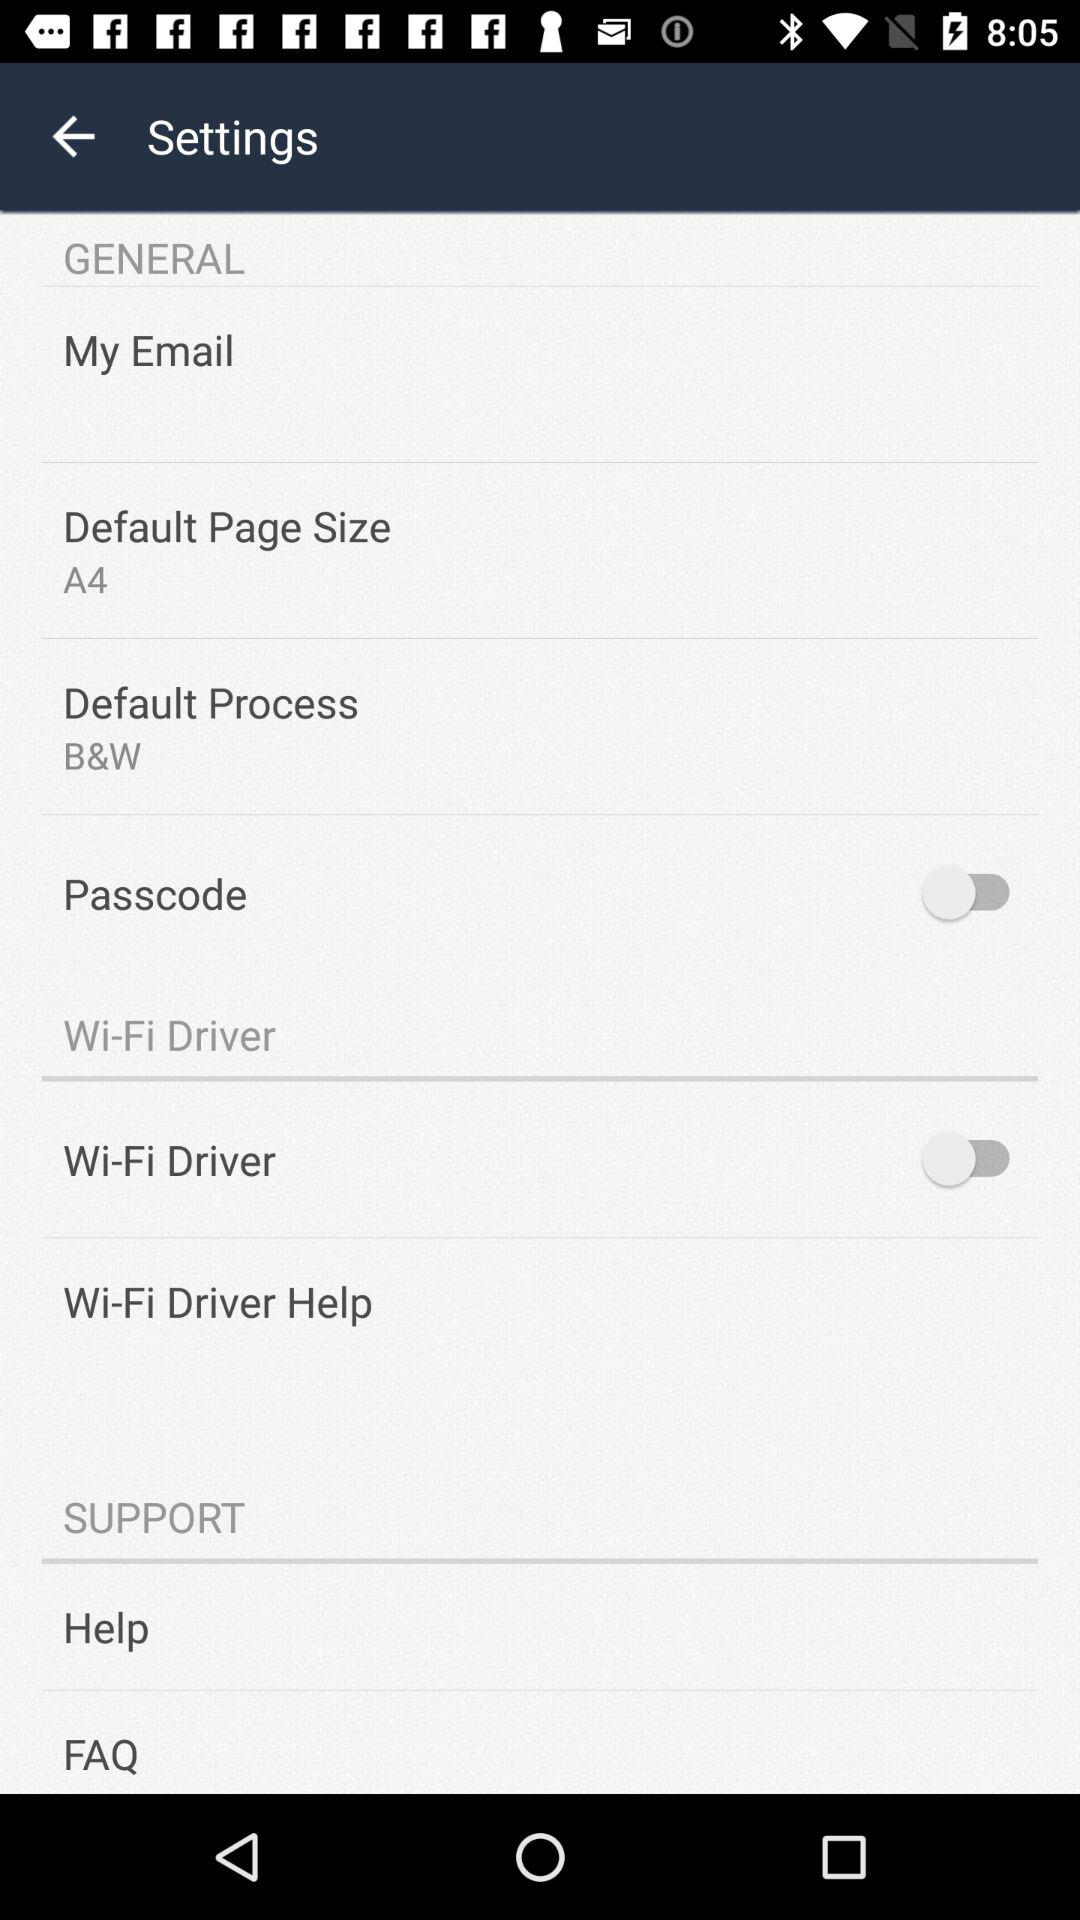Which page size has been set as the default? The default page size is A4. 